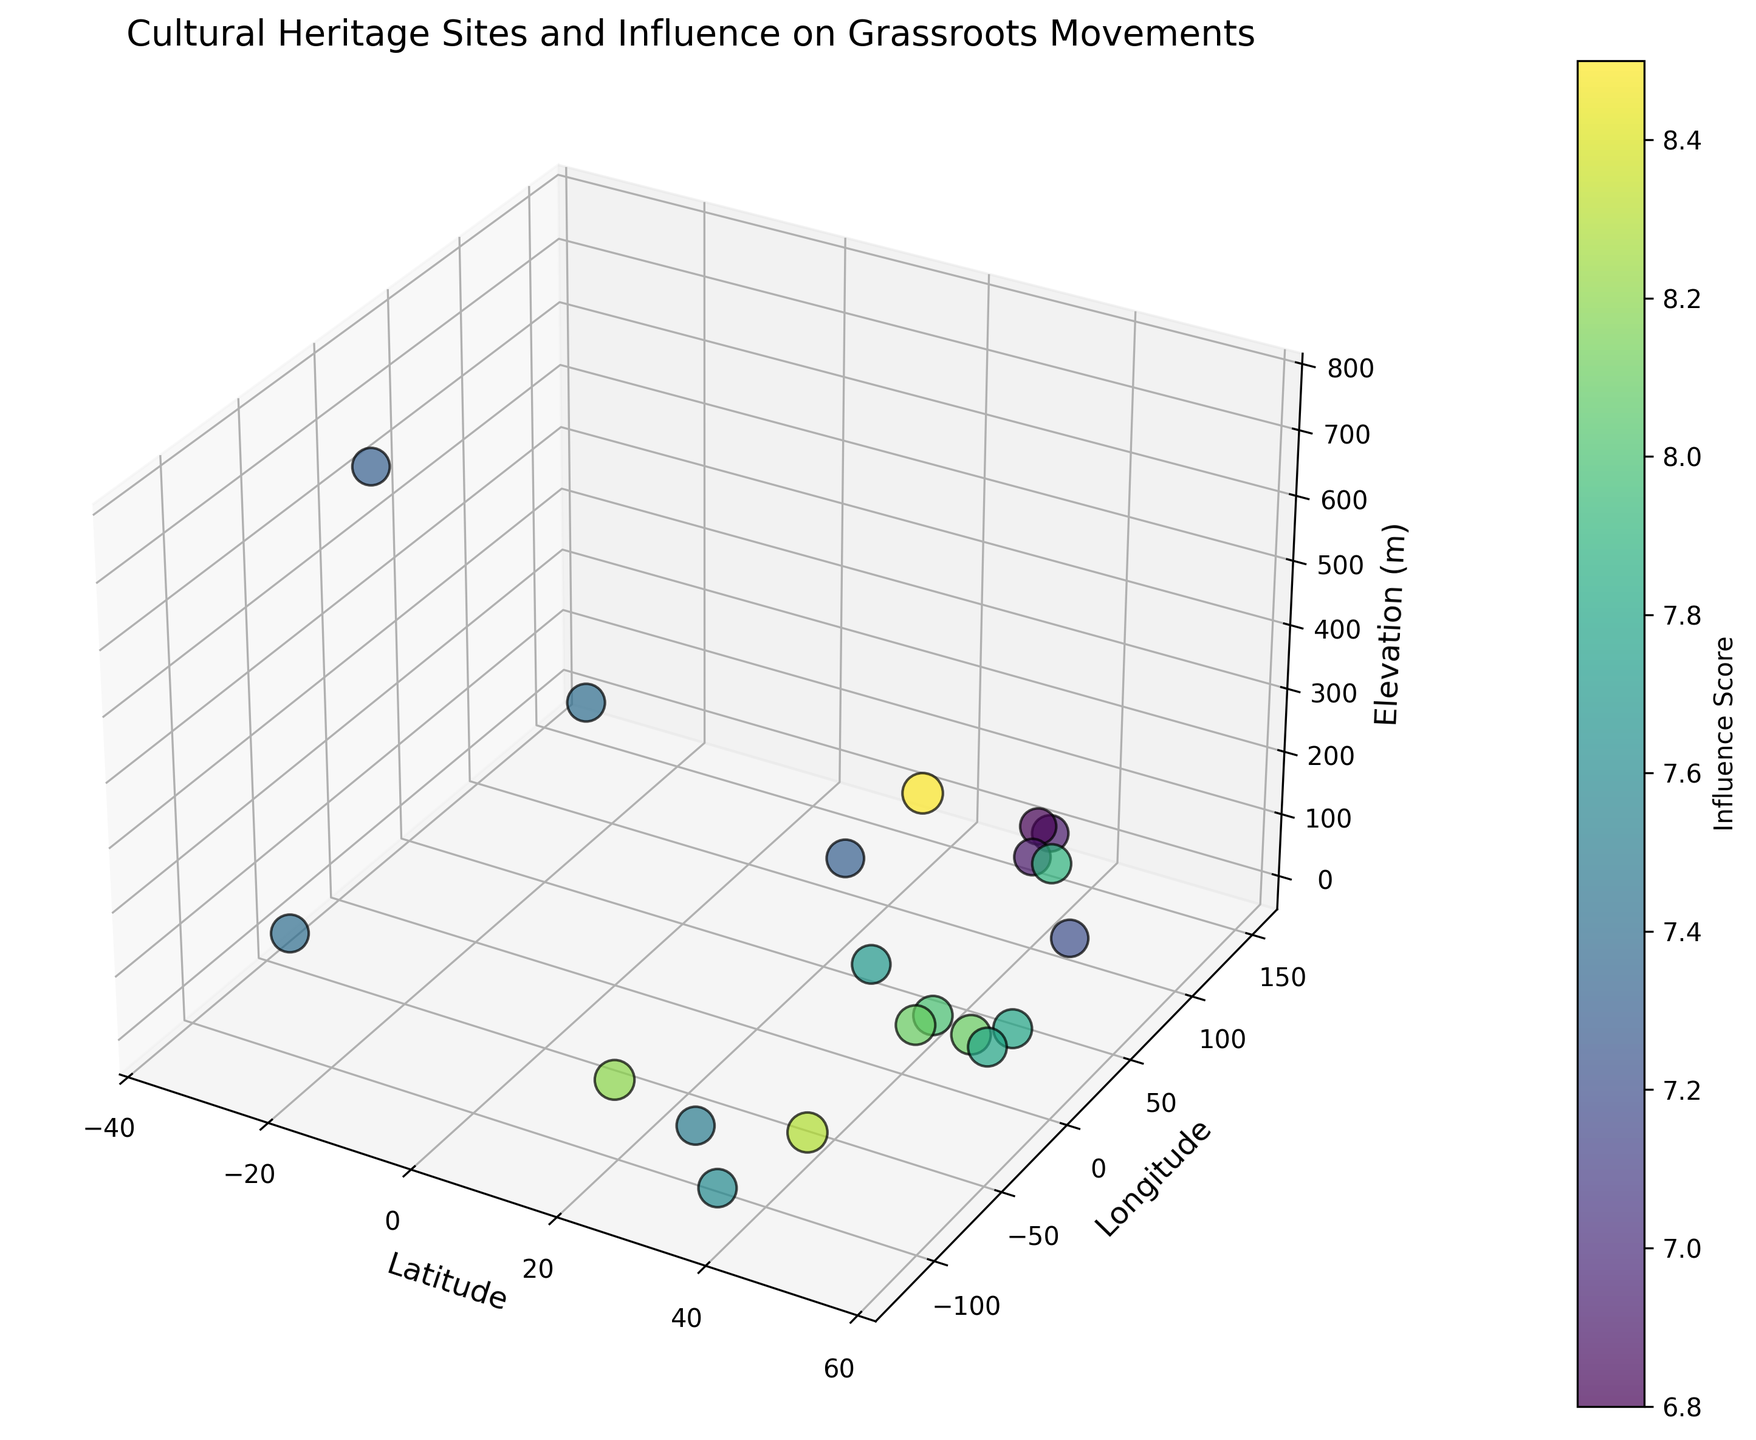What's the city with the highest influence score? By looking at the color bar and the size of the markers, the city with the highest influence score corresponds to the largest and brightest marker. Referring to the data, New Delhi (latitude 28.6139, longitude 77.2090) has the highest influence score of 8.5.
Answer: New Delhi Which city has a higher elevation: São Paulo or New York City? From the 3D plot, comparing the vertical positions (elevations) of the markers placed at São Paulo (latitude -23.5505, longitude -46.6333) and New York City (latitude 40.7128, longitude -74.0060), São Paulo marker is located higher. Referring to the data, São Paulo’s elevation is 760 meters, while New York City's elevation is 10 meters.
Answer: São Paulo What is the average elevation of the cities in the dataset? First, sum the elevations of all cities: 89 + 10 + 30 + 35 + 40 + 140 + 50 + 20 + 15 + 35 + 5 + 56 + 67 + 760 + 20 + 24 + 22 + 25 + 200 + 1 = 1644. Then, divide by the number of cities, which is 20. 1644 / 20 = 82.2
Answer: 82.2 Is the influence score of Paris higher than that of Tokyo? From the 3D plot, check the colors of the markers for Paris (latitude 48.8566, longitude 2.3522) and Tokyo (latitude 35.6895, longitude 139.6917). Paris has a darker color indicating a higher influence score. Referring to the data, Paris has an influence score of 8.1 while Tokyo's is 6.9.
Answer: Yes Which location has the least elevation among the cities compared? By observing the vertical positions of the markers on the plot, the marker at Bangkok (latitude 13.7563, longitude 100.5018) is the lowest. Referring to the data, its elevation is 1 meter.
Answer: Bangkok What is the largest difference in influence scores between any two cities? First, identify the maximum (New Delhi: 8.5) and minimum (Tokyo and Busan: 6.8) influence scores from the data. The difference is 8.5 - 6.8 = 1.7
Answer: 1.7 Compare the influence scores between cities with elevations below 50 meters, which has the highest? From the data for cities with elevations below 50 meters: New York City (8.3), Paris (8.1), Rome (8.0), San Francisco (7.6), Buenos Aires (7.4), Sydney (7.4), Barcelona (8.1), Cairo (7.7), Bangkok (7.3). New York City has the highest influence score of 8.3
Answer: New York City What is the median influence score of all the cities? First, list the influence scores in ascending order: 6.8, 6.8, 6.9, 6.9, 7.2, 7.3, 7.3, 7.4, 7.4, 7.5, 7.6, 7.7, 7.8, 7.8, 7.9, 8.0, 8.1, 8.1, 8.2, 8.3, 8.5. Since there are 20 data points, the median is the average of the 10th and 11th values: (7.5 + 7.6) / 2 = 7.55
Answer: 7.55 